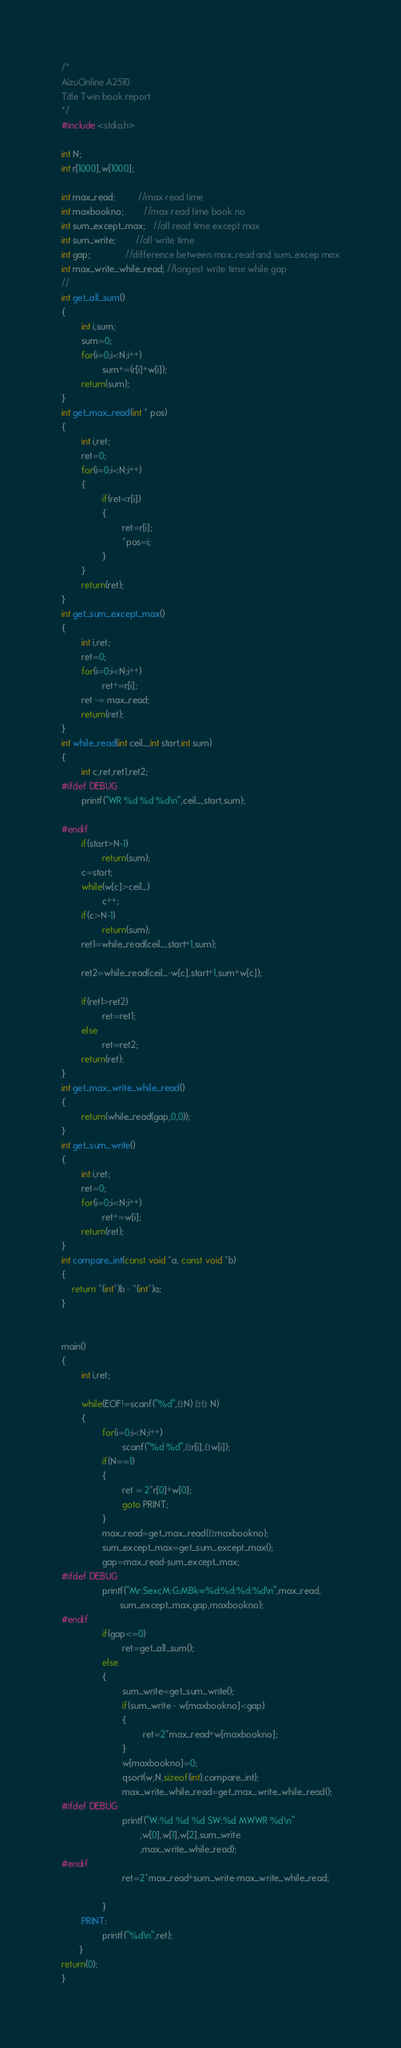<code> <loc_0><loc_0><loc_500><loc_500><_C_>/*
AizuOnline A2510
Title Twin book report
*/
#include <stdio.h>

int N;
int r[1000],w[1000];

int max_read;         //max read time
int maxbookno;        //max read time book no
int sum_except_max;   //all read time except max
int sum_write;        //all write time
int gap;              //difference between max_read and sum_excep max
int max_write_while_read; //longest write time while gap
//
int get_all_sum()
{
        int i,sum;
        sum=0;
        for(i=0;i<N;i++)
                sum+=(r[i]+w[i]);
        return(sum);
}
int get_max_read(int * pos)
{
        int i,ret;
        ret=0;
        for(i=0;i<N;i++)
        {
                if(ret<r[i])
                {
                        ret=r[i];
                        *pos=i;
                }
        }
        return(ret);
}
int get_sum_except_max()
{
        int i,ret;
        ret=0;
        for(i=0;i<N;i++)
                ret+=r[i];
        ret -= max_read;
        return(ret);
}
int while_read(int ceil_,int start,int sum)
{
        int c,ret,ret1,ret2;
#ifdef DEBUG
        printf("WR %d %d %d\n",ceil_,start,sum);

#endif
        if(start>N-1)
                return(sum);
        c=start;
        while(w[c]>ceil_)
                c++;
        if(c>N-1)
                return(sum);
        ret1=while_read(ceil_,start+1,sum);

        ret2=while_read(ceil_-w[c],start+1,sum+w[c]);

        if(ret1>ret2)
                ret=ret1;
        else
                ret=ret2;
        return(ret);
}
int get_max_write_while_read()
{
        return(while_read(gap,0,0));
}
int get_sum_write()
{
        int i,ret;
        ret=0;
        for(i=0;i<N;i++)
                ret+=w[i];
        return(ret);
}
int compare_int(const void *a, const void *b)
{
    return *(int*)b - *(int*)a;
}


main()
{
        int i,ret;

        while(EOF!=scanf("%d",&N) && N)
        {
                for(i=0;i<N;i++)
                        scanf("%d %d",&r[i],&w[i]);
                if(N==1)
                {
                        ret = 2*r[0]+w[0];
                        goto PRINT;
                }
                max_read=get_max_read(&maxbookno);
                sum_except_max=get_sum_except_max();
                gap=max_read-sum_except_max;
#ifdef DEBUG
                printf("Mr:SexcM:G:MBk=%d:%d:%d:%d\n",max_read,
                       sum_except_max,gap,maxbookno);
#endif
                if(gap<=0)
                        ret=get_all_sum();
                else
                {
                        sum_write=get_sum_write();
                        if(sum_write - w[maxbookno]<gap)
                        {
                                ret=2*max_read+w[maxbookno];
                        }
                        w[maxbookno]=0;
                        qsort(w,N,sizeof(int),compare_int);
                        max_write_while_read=get_max_write_while_read();
#ifdef DEBUG
                        printf("W:%d %d %d SW:%d MWWR %d\n"
                               ,w[0],w[1],w[2],sum_write
                               ,max_write_while_read);
#endif
                        ret=2*max_read+sum_write-max_write_while_read;

                }
        PRINT:
                printf("%d\n",ret);
       }
return(0);
}</code> 